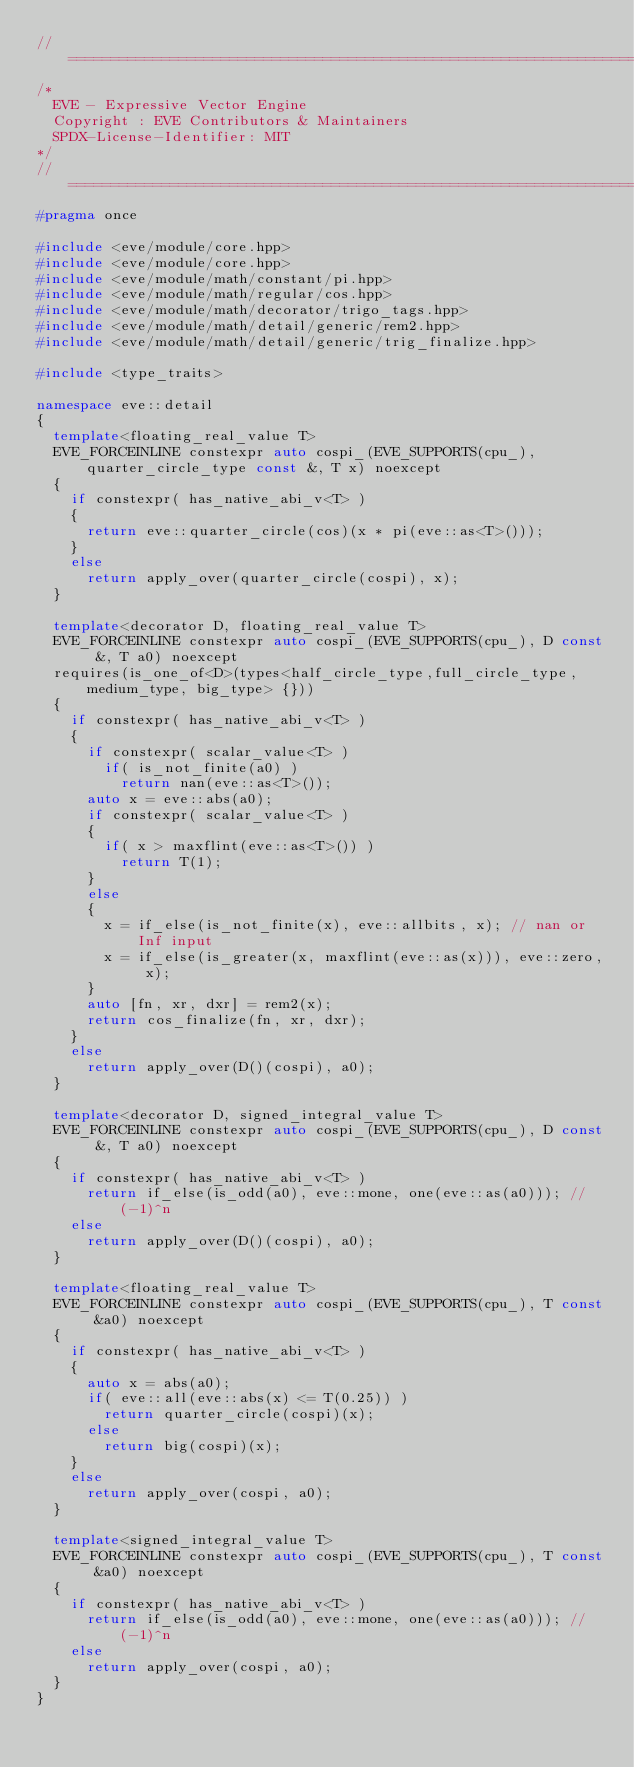<code> <loc_0><loc_0><loc_500><loc_500><_C++_>//==================================================================================================
/*
  EVE - Expressive Vector Engine
  Copyright : EVE Contributors & Maintainers
  SPDX-License-Identifier: MIT
*/
//==================================================================================================
#pragma once

#include <eve/module/core.hpp>
#include <eve/module/core.hpp>
#include <eve/module/math/constant/pi.hpp>
#include <eve/module/math/regular/cos.hpp>
#include <eve/module/math/decorator/trigo_tags.hpp>
#include <eve/module/math/detail/generic/rem2.hpp>
#include <eve/module/math/detail/generic/trig_finalize.hpp>

#include <type_traits>

namespace eve::detail
{
  template<floating_real_value T>
  EVE_FORCEINLINE constexpr auto cospi_(EVE_SUPPORTS(cpu_), quarter_circle_type const &, T x) noexcept
  {
    if constexpr( has_native_abi_v<T> )
    {
      return eve::quarter_circle(cos)(x * pi(eve::as<T>()));
    }
    else
      return apply_over(quarter_circle(cospi), x);
  }

  template<decorator D, floating_real_value T>
  EVE_FORCEINLINE constexpr auto cospi_(EVE_SUPPORTS(cpu_), D const &, T a0) noexcept
  requires(is_one_of<D>(types<half_circle_type,full_circle_type, medium_type, big_type> {}))
  {
    if constexpr( has_native_abi_v<T> )
    {
      if constexpr( scalar_value<T> )
        if( is_not_finite(a0) )
          return nan(eve::as<T>());
      auto x = eve::abs(a0);
      if constexpr( scalar_value<T> )
      {
        if( x > maxflint(eve::as<T>()) )
          return T(1);
      }
      else
      {
        x = if_else(is_not_finite(x), eve::allbits, x); // nan or Inf input
        x = if_else(is_greater(x, maxflint(eve::as(x))), eve::zero, x);
      }
      auto [fn, xr, dxr] = rem2(x);
      return cos_finalize(fn, xr, dxr);
    }
    else
      return apply_over(D()(cospi), a0);
  }

  template<decorator D, signed_integral_value T>
  EVE_FORCEINLINE constexpr auto cospi_(EVE_SUPPORTS(cpu_), D const &, T a0) noexcept
  {
    if constexpr( has_native_abi_v<T> )
      return if_else(is_odd(a0), eve::mone, one(eve::as(a0))); //(-1)^n
    else
      return apply_over(D()(cospi), a0);
  }

  template<floating_real_value T>
  EVE_FORCEINLINE constexpr auto cospi_(EVE_SUPPORTS(cpu_), T const &a0) noexcept
  {
    if constexpr( has_native_abi_v<T> )
    {
      auto x = abs(a0);
      if( eve::all(eve::abs(x) <= T(0.25)) )
        return quarter_circle(cospi)(x);
      else
        return big(cospi)(x);
    }
    else
      return apply_over(cospi, a0);
  }

  template<signed_integral_value T>
  EVE_FORCEINLINE constexpr auto cospi_(EVE_SUPPORTS(cpu_), T const &a0) noexcept
  {
    if constexpr( has_native_abi_v<T> )
      return if_else(is_odd(a0), eve::mone, one(eve::as(a0))); //(-1)^n
    else
      return apply_over(cospi, a0);
  }
}
</code> 